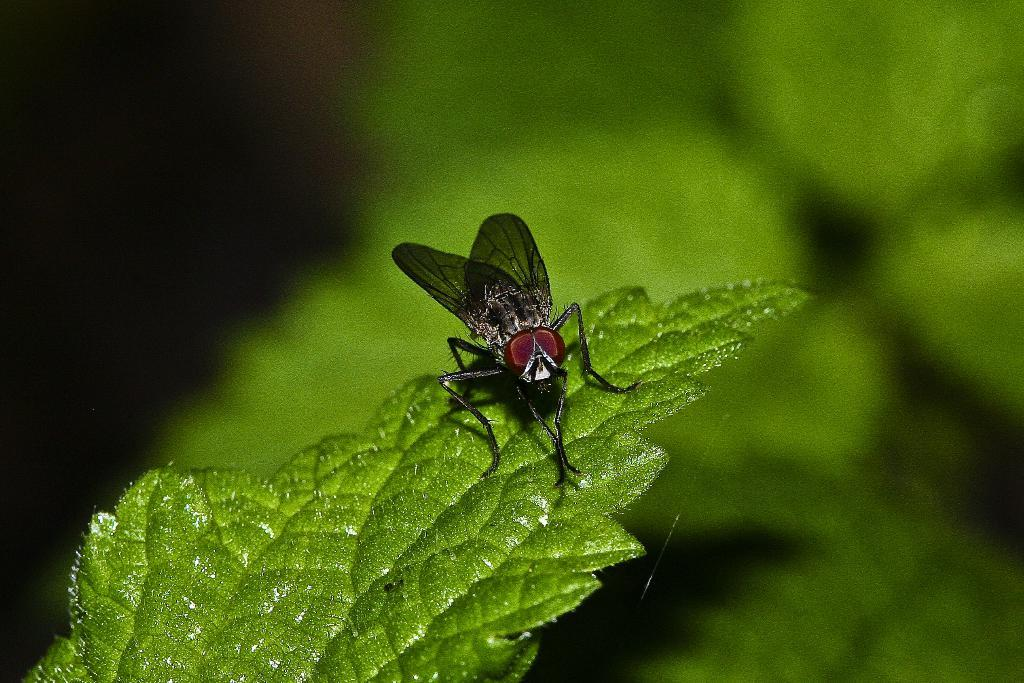What type of bug can be seen in the image? There is a black color bug in the image. Where is the bug located? The bug is sitting on a green leaf. Can you describe the background of the image? The background of the image is blurred. What type of magic is the bug performing on the stranger in the image? There is no stranger present in the image, and the bug is not performing any magic. 